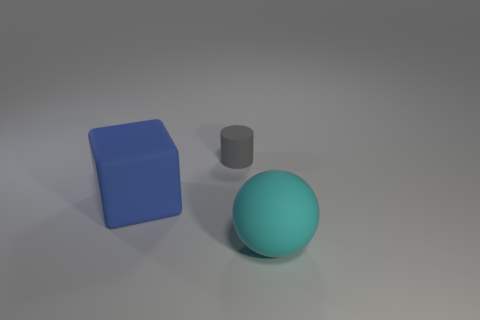Is there anything else that is the same size as the gray matte cylinder?
Your response must be concise. No. What number of things are small blue things or cyan objects?
Provide a succinct answer. 1. Are there fewer tiny matte objects that are to the right of the small gray object than big matte things?
Your answer should be very brief. Yes. Is the number of rubber things right of the gray matte cylinder greater than the number of rubber balls on the left side of the cyan matte thing?
Your answer should be compact. Yes. There is a large thing behind the cyan ball; what is it made of?
Your answer should be very brief. Rubber. Is the rubber ball the same size as the block?
Offer a very short reply. Yes. What number of other objects are there of the same size as the blue rubber block?
Ensure brevity in your answer.  1. What shape is the thing behind the big rubber thing left of the object in front of the rubber block?
Offer a very short reply. Cylinder. How many things are rubber objects behind the blue rubber thing or gray matte cylinders behind the blue matte object?
Provide a short and direct response. 1. How big is the matte thing that is in front of the big matte thing that is behind the big cyan rubber object?
Ensure brevity in your answer.  Large. 